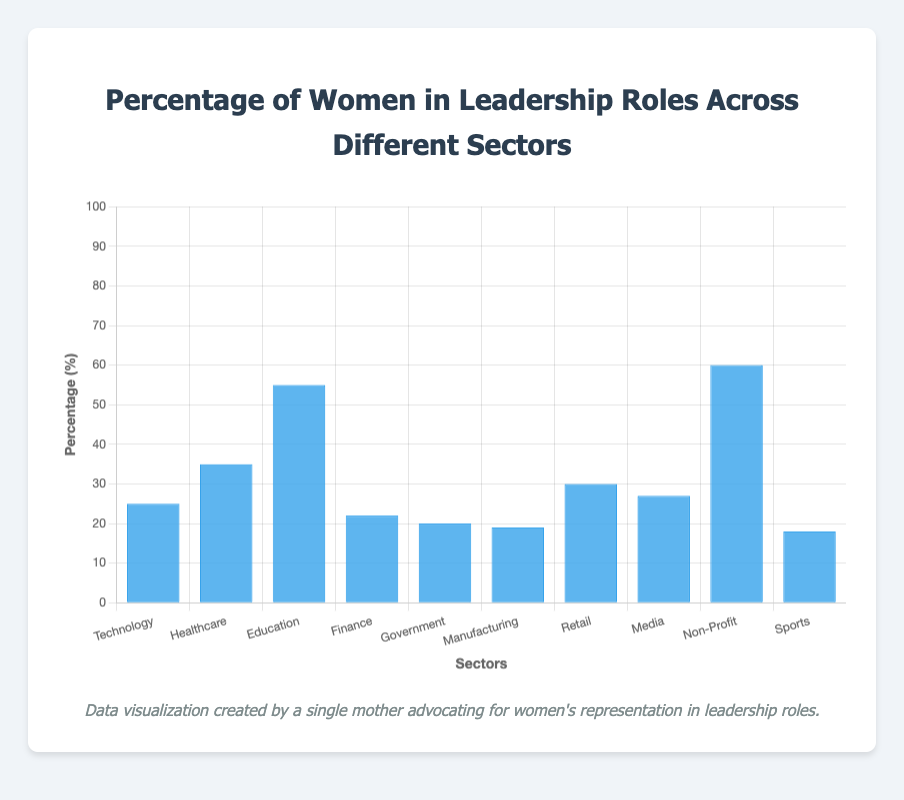Which sector has the highest percentage of women in leadership roles? The sector with the highest percentage of women in leadership roles can be identified by comparing the height of the bars. The highest bar corresponds to the Non-Profit sector with 60%.
Answer: Non-Profit Which sector has the lowest percentage of women in leadership roles? The sector with the lowest percentage can be identified by finding the shortest bar. The Sports sector has the shortest bar at 18%.
Answer: Sports Between Technology and Healthcare, which sector has more women in leadership roles and by what percentage? Compare the bars for Technology and Healthcare. Healthcare has a higher percentage (35%) compared to Technology (25%). The difference is 35% - 25% = 10%.
Answer: Healthcare, 10% What is the average percentage of women in leadership roles in all sectors? Add all the percentages and divide by the number of sectors: (25 + 35 + 55 + 22 + 20 + 19 + 30 + 27 + 60 + 18) / 10 = 31.1%
Answer: 31.1% How does the percentage of women in leadership roles in the Government sector compare to the Media sector? Compare the Government (20%) to the Media (27%) by observing their respective bar heights. The Media sector has a higher percentage.
Answer: Media has a higher percentage By what percentage does the Education sector exceed the Finance sector in women leadership roles? Compare Education (55%) and Finance (22%). The difference is 55% - 22% = 33%.
Answer: 33% Which sectors have a percentage of women in leadership roles below 25%? Identify bars with heights below 25%. These sectors are Finance (22%), Government (20%), Manufacturing (19%), and Sports (18%).
Answer: Finance, Government, Manufacturing, Sports What is the total percentage of women in leadership roles across the Technology, Healthcare, and Retail sectors? Add the percentages for Technology (25%), Healthcare (35%), and Retail (30%): 25% + 35% + 30% = 90%.
Answer: 90% How does the average percentage of women in leadership roles in Finance, Government, and Manufacturing compare to the overall average across all sectors? Calculate the average for Finance, Government, and Manufacturing: (22 + 20 + 19) / 3 = 20.33%. The overall average is 31.1%. The average in these sectors is lower than the overall average.
Answer: Lower What is the range of the percentages of women in leadership roles across the sectors? The range is the difference between the highest and lowest values: 60% (Non-Profit) - 18% (Sports) = 42%.
Answer: 42% 